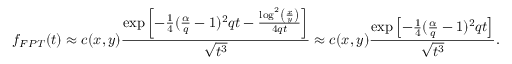<formula> <loc_0><loc_0><loc_500><loc_500>f _ { F P T } ( t ) \approx c ( x , y ) \frac { \exp \left [ - \frac { 1 } { 4 } ( \frac { \alpha } { q } - 1 ) ^ { 2 } q t - \frac { \log ^ { 2 } \left ( \frac { x } { y } \right ) } { 4 q t } \right ] } { \sqrt { t ^ { 3 } } } \approx c ( x , y ) \frac { \exp \left [ - \frac { 1 } { 4 } ( \frac { \alpha } { q } - 1 ) ^ { 2 } q t \right ] } { \sqrt { t ^ { 3 } } } .</formula> 